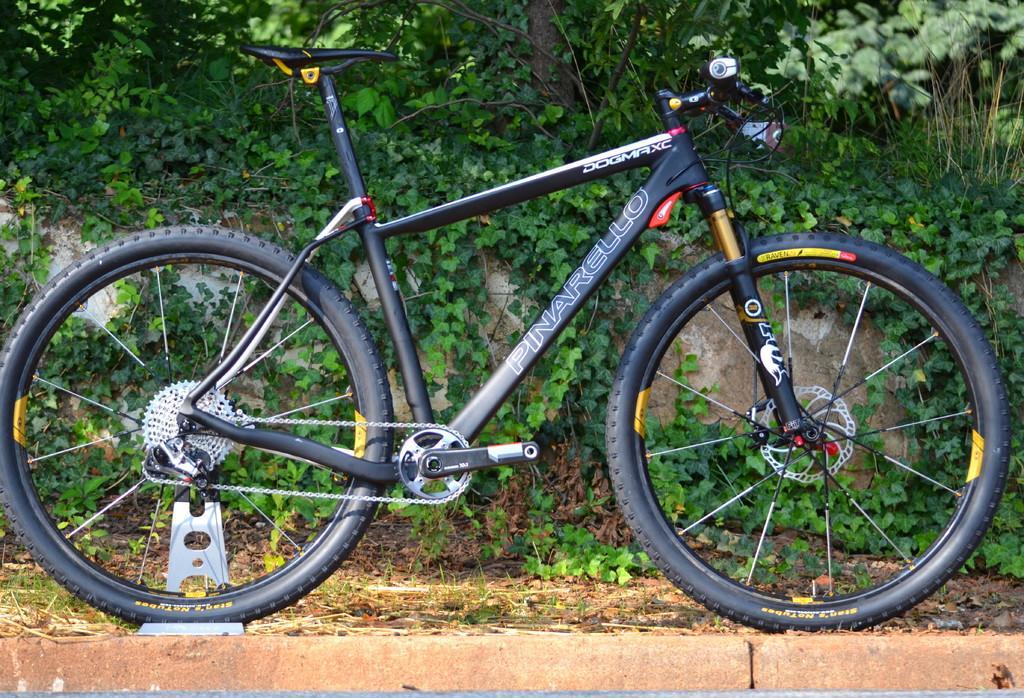Could you give a brief overview of what you see in this image? In this picture there is a black color bicycle parked on the footpath. Behind there are some green leaves and plants. 